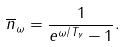<formula> <loc_0><loc_0><loc_500><loc_500>\overline { n } _ { \omega } = \frac { 1 } { e ^ { \omega / T _ { \gamma } } - 1 } .</formula> 